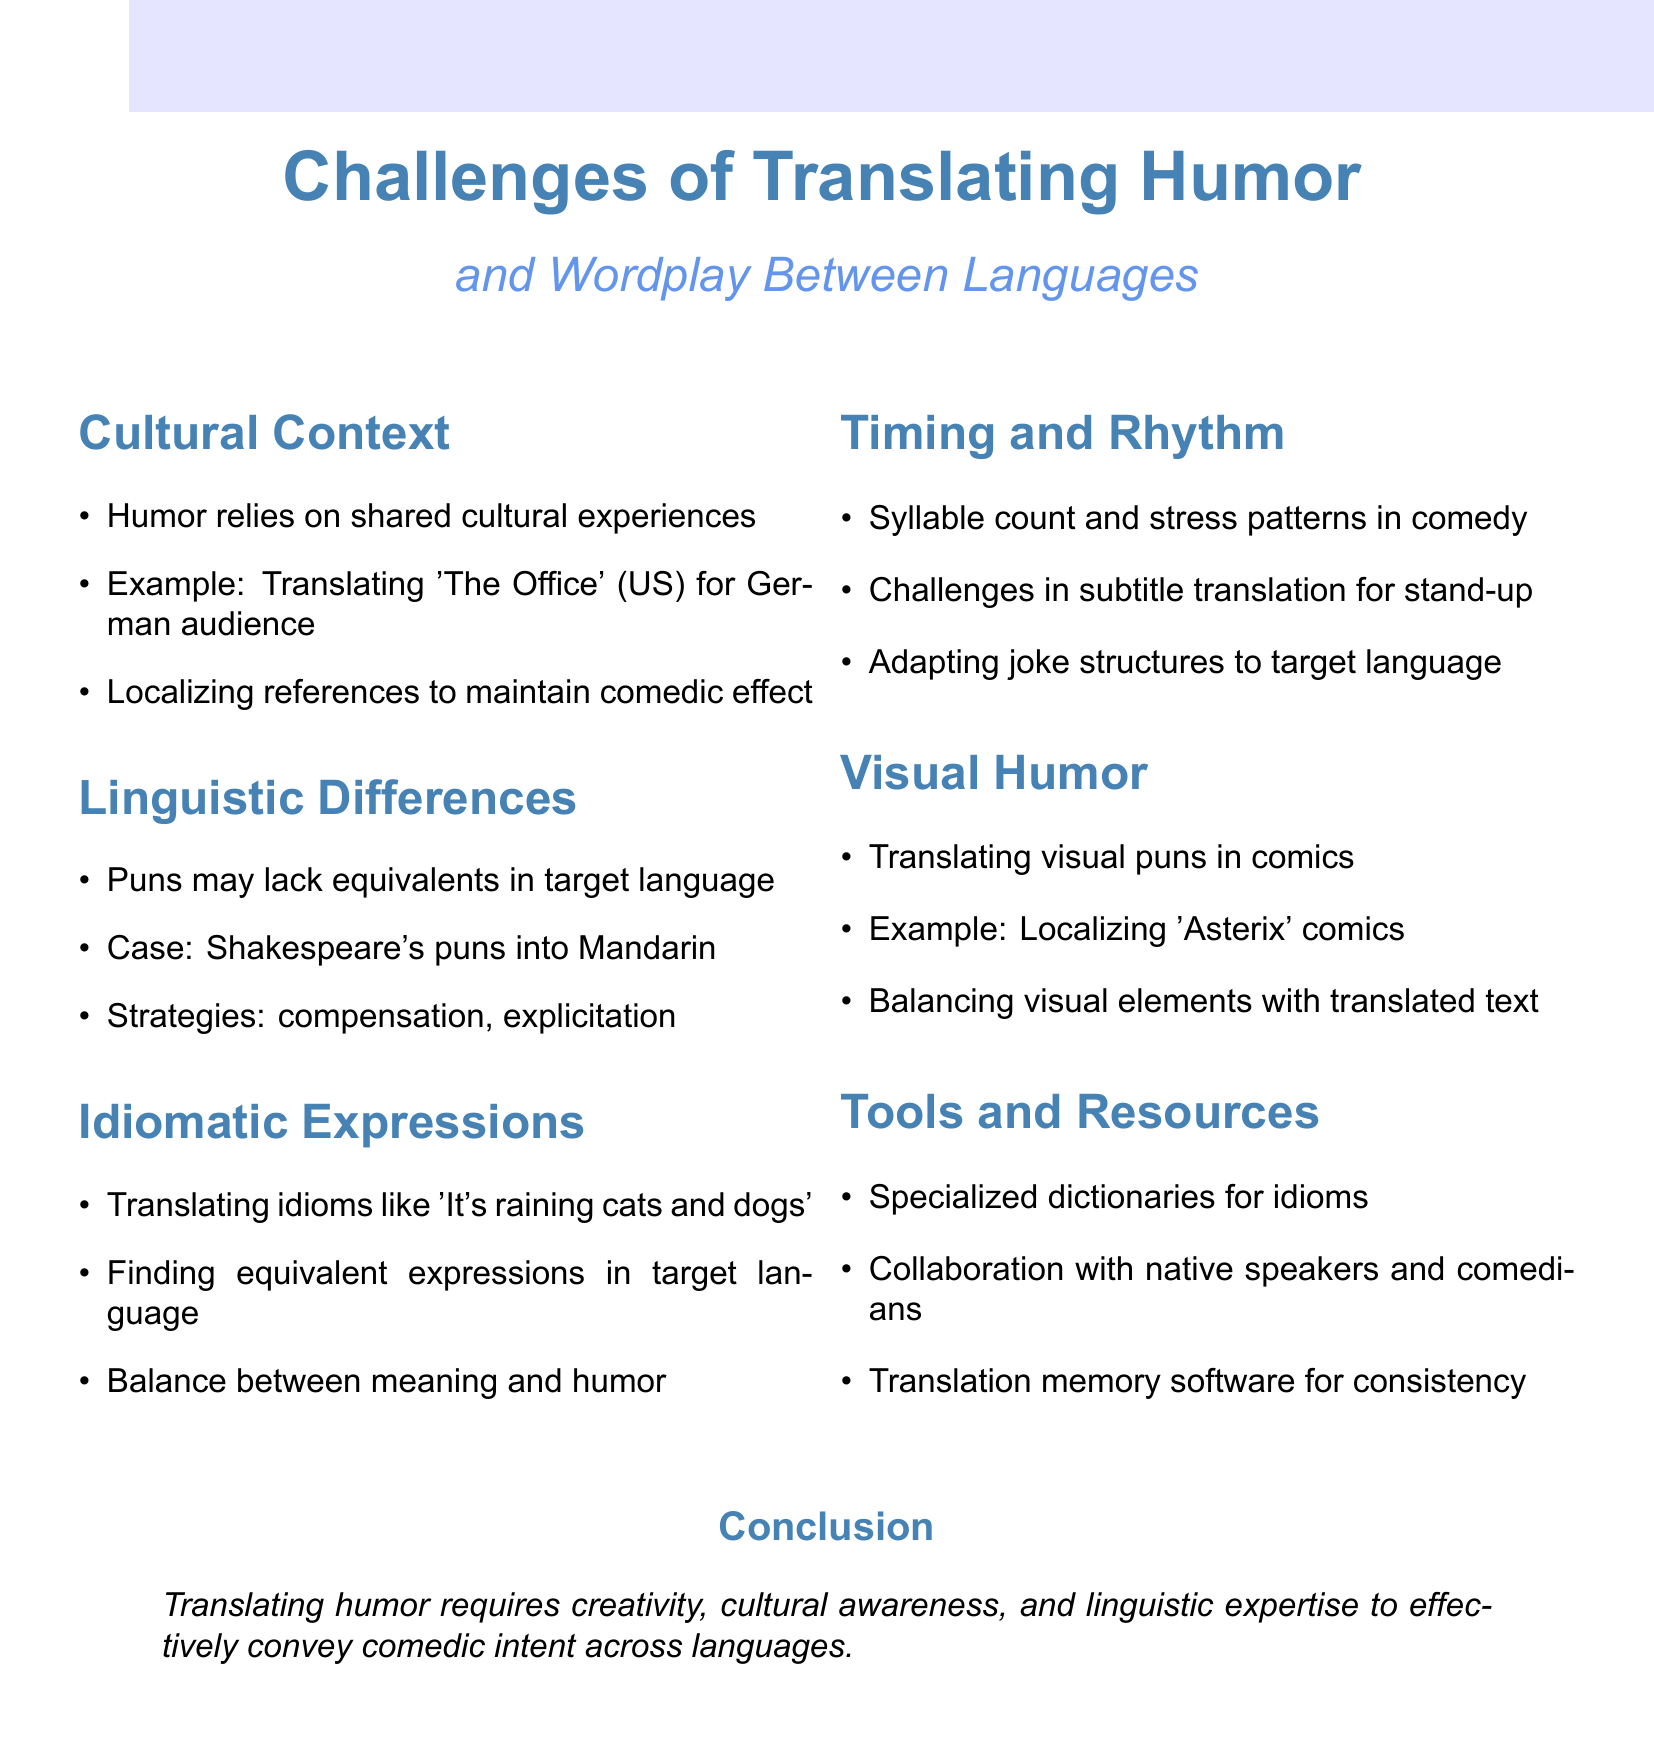What is the title of the document? The title is given at the beginning of the document and is “Challenges of Translating Humor and Wordplay Between Languages.”
Answer: Challenges of Translating Humor and Wordplay Between Languages How many key points are discussed in the document? The document lists six key points under the main theme, indicating the number of sections included.
Answer: 6 Which example is used for the cultural context challenge? An example is mentioned under cultural context in translating 'The Office' for a specific audience.
Answer: Translating 'The Office' (US) What is one strategy for preserving wordplay? The document lists strategies for wordplay preservation including compensation and explicitation, indicating practical methods used by translators.
Answer: compensation What idiom is mentioned as being difficult to translate? The document gives an idiomatic expression as an example to showcase translation difficulties and discusses its translation challenges.
Answer: It's raining cats and dogs What is the main conclusion of the document? The conclusion summarizes the overall requirement for effectively conveying humor across languages based on the prior discussions in the document.
Answer: Creativity, cultural awareness, and linguistic expertise 